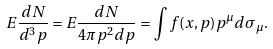Convert formula to latex. <formula><loc_0><loc_0><loc_500><loc_500>E { \frac { d N } { d ^ { 3 } p } } = E { \frac { d N } { 4 \pi p ^ { 2 } d p } } = \int f ( x , p ) p ^ { \mu } d \sigma _ { \mu } .</formula> 